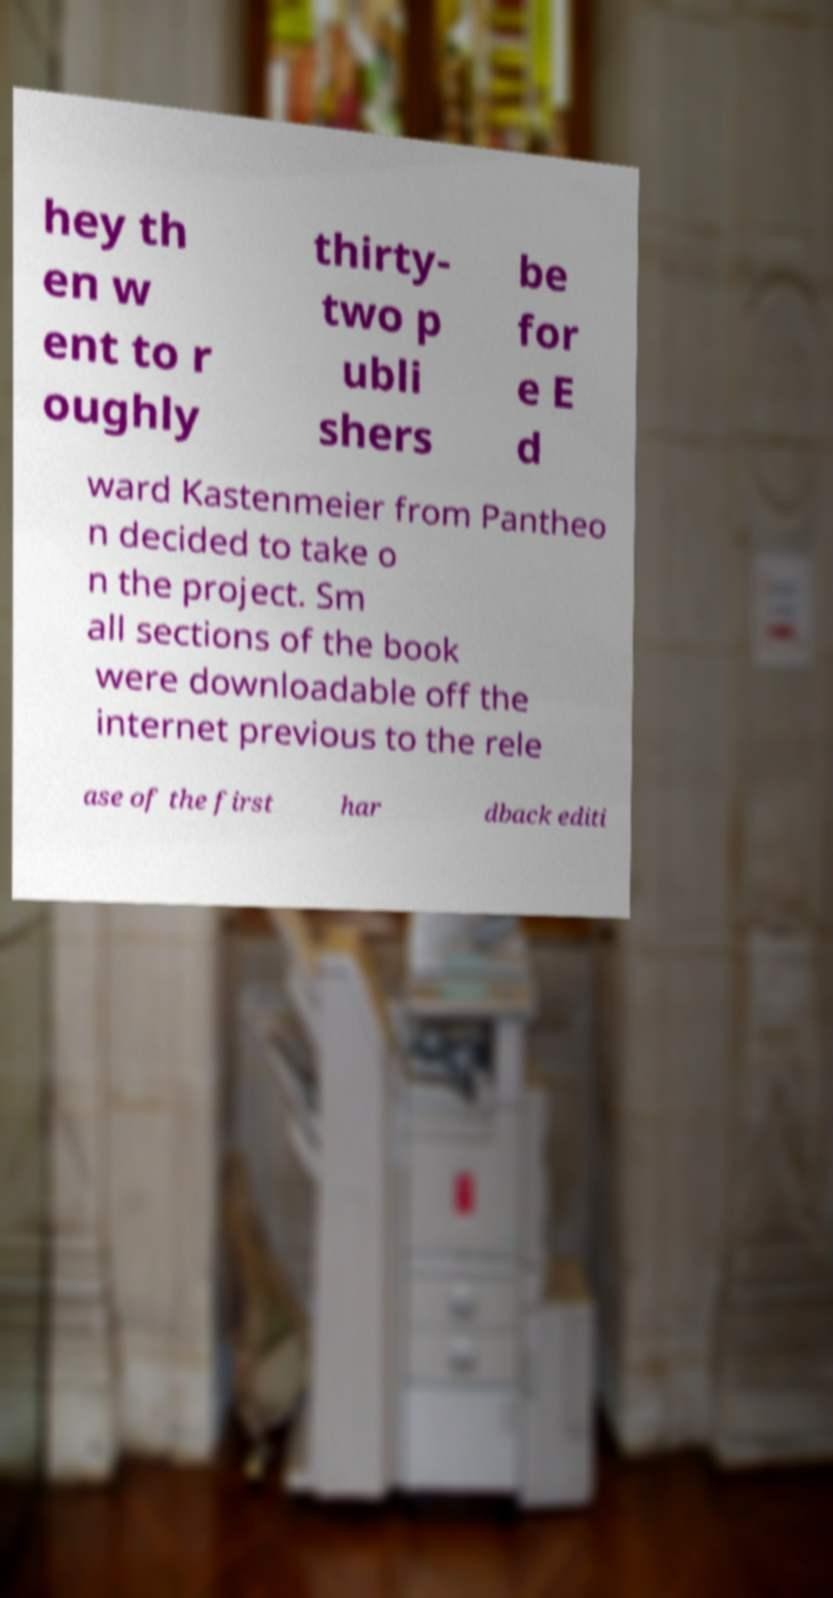Please identify and transcribe the text found in this image. hey th en w ent to r oughly thirty- two p ubli shers be for e E d ward Kastenmeier from Pantheo n decided to take o n the project. Sm all sections of the book were downloadable off the internet previous to the rele ase of the first har dback editi 